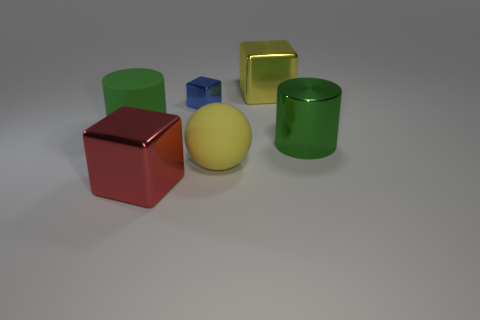Subtract all big blocks. How many blocks are left? 1 Add 2 red things. How many objects exist? 8 Subtract all balls. How many objects are left? 5 Add 6 yellow spheres. How many yellow spheres are left? 7 Add 4 red metallic blocks. How many red metallic blocks exist? 5 Subtract 2 green cylinders. How many objects are left? 4 Subtract all yellow rubber objects. Subtract all purple rubber things. How many objects are left? 5 